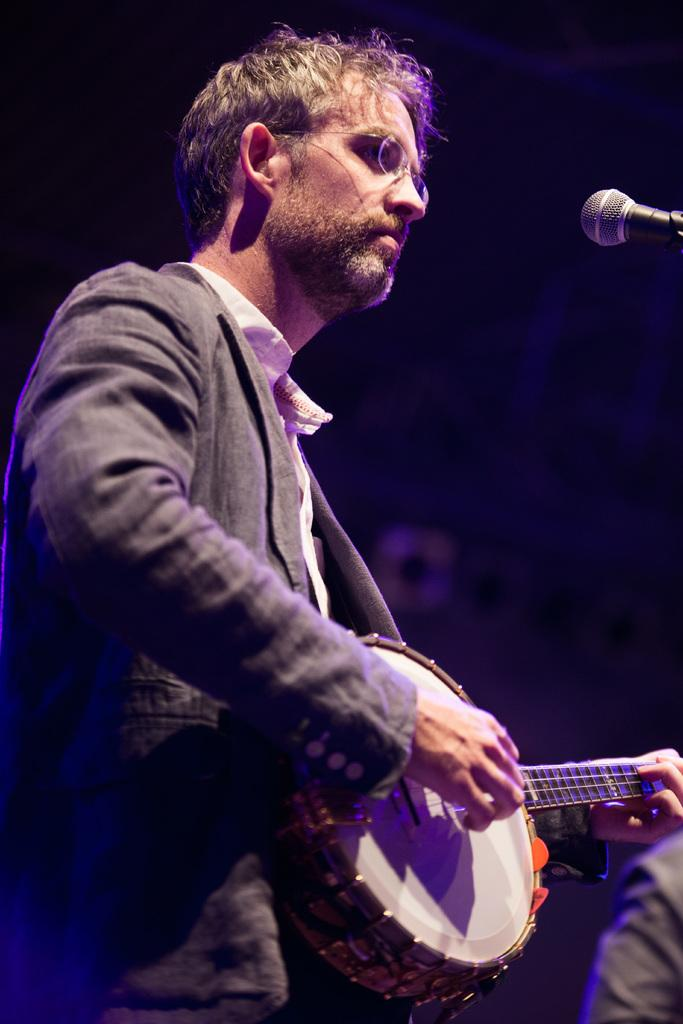What is the man in the image doing? The man is playing a musical instrument in the image. What can be seen on the right side of the image? There is a mile and a person on the right side of the image. Can you describe the person on the right side of the image? The person is on the right side of the image, but no specific details about their appearance or actions are provided. How would you describe the background of the image? The background of the image is blurry. What type of powder is being used by the person on the right side of the image? There is no powder visible in the image, and no information is provided about the person's actions or activities. What color is the skin of the person on the right side of the image? The person's skin color is not mentioned in the provided facts, so it cannot be determined from the image. 